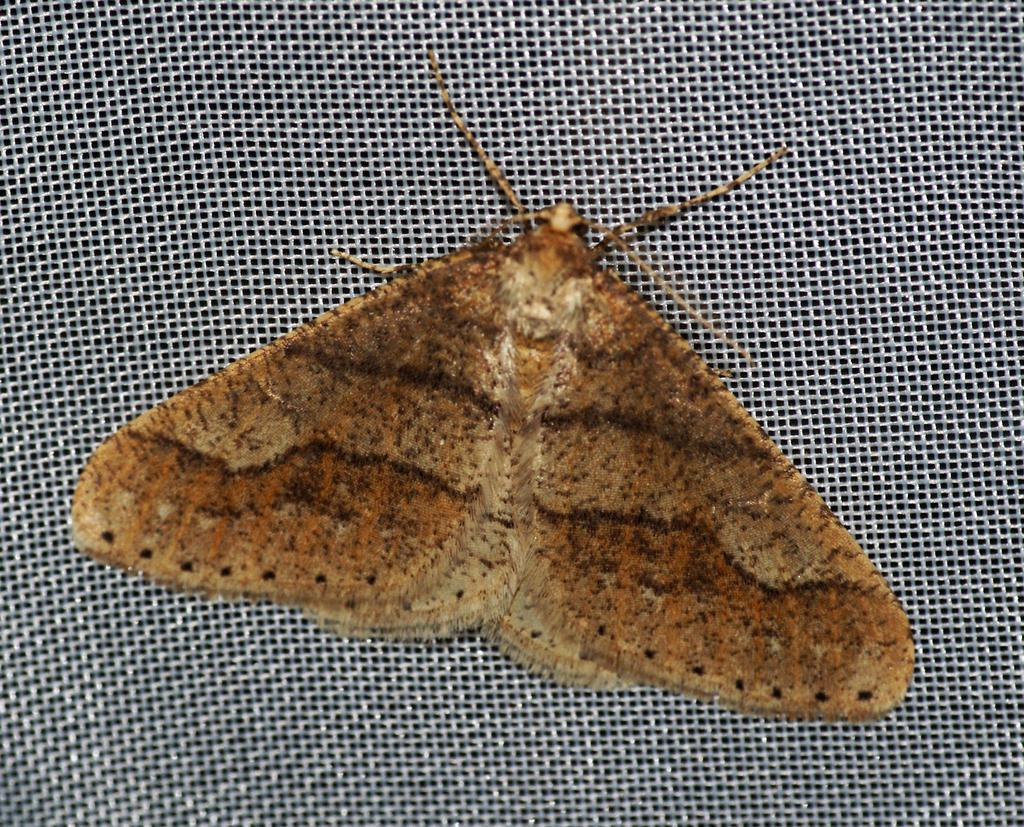What is the main subject in the center of the image? There is a fly in the center of the image. What song is the fly singing in the image? Flies do not have the ability to sing songs, so there is no song being sung by the fly in the image. 